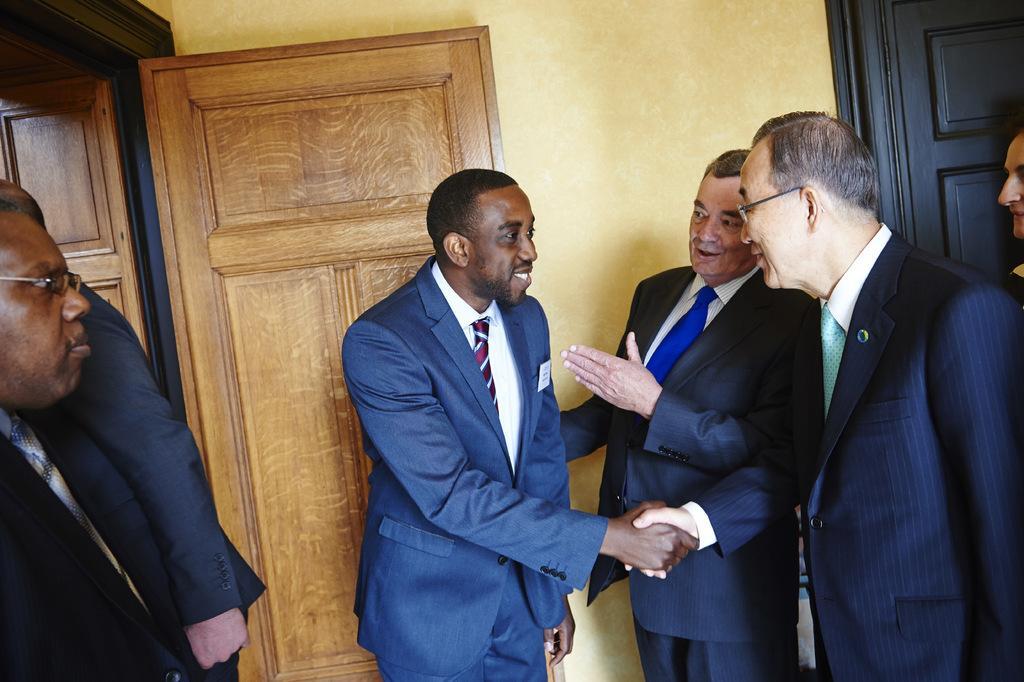Please provide a concise description of this image. In this picture there are some men wearing blue suit and welcoming the guest by shaking hand. Behind there is a brown wooden door and yellow wall. 